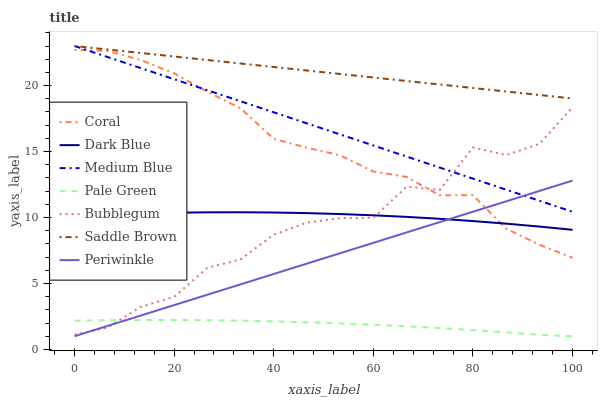Does Medium Blue have the minimum area under the curve?
Answer yes or no. No. Does Medium Blue have the maximum area under the curve?
Answer yes or no. No. Is Medium Blue the smoothest?
Answer yes or no. No. Is Medium Blue the roughest?
Answer yes or no. No. Does Medium Blue have the lowest value?
Answer yes or no. No. Does Bubblegum have the highest value?
Answer yes or no. No. Is Pale Green less than Medium Blue?
Answer yes or no. Yes. Is Saddle Brown greater than Dark Blue?
Answer yes or no. Yes. Does Pale Green intersect Medium Blue?
Answer yes or no. No. 